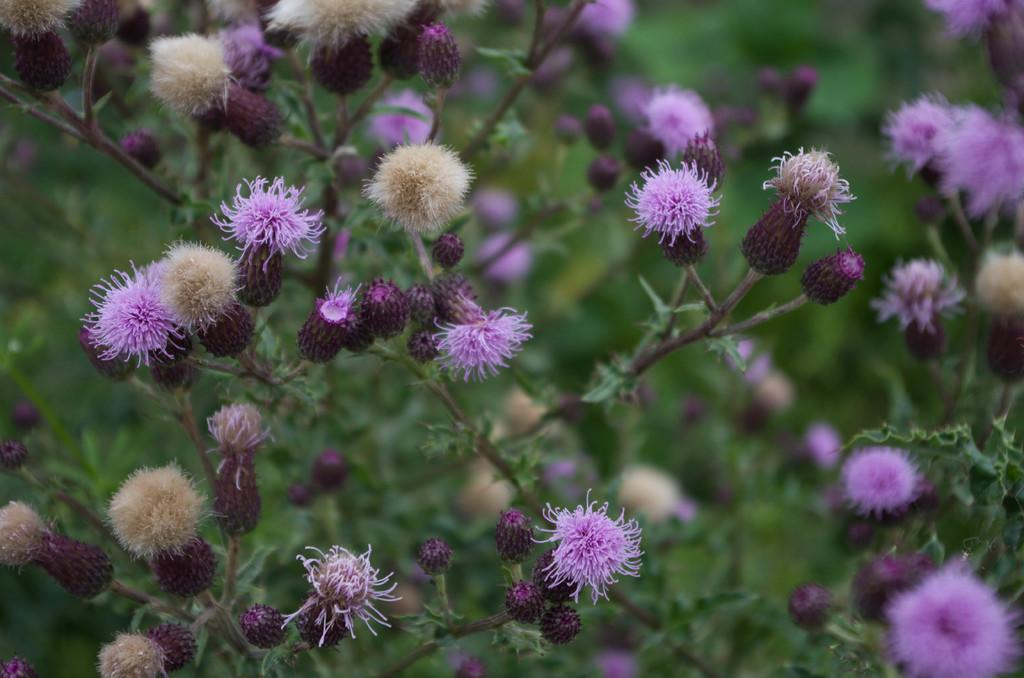What type of flowers are in the middle of the picture? There are violet color flowers in the middle of the picture. Can you describe the background of the image? The background of the image is blurred. How many rabbits can be seen playing with a heart-shaped balloon in the image? There are no rabbits or heart-shaped balloons present in the image; it features violet color flowers in the middle and a blurred background. 